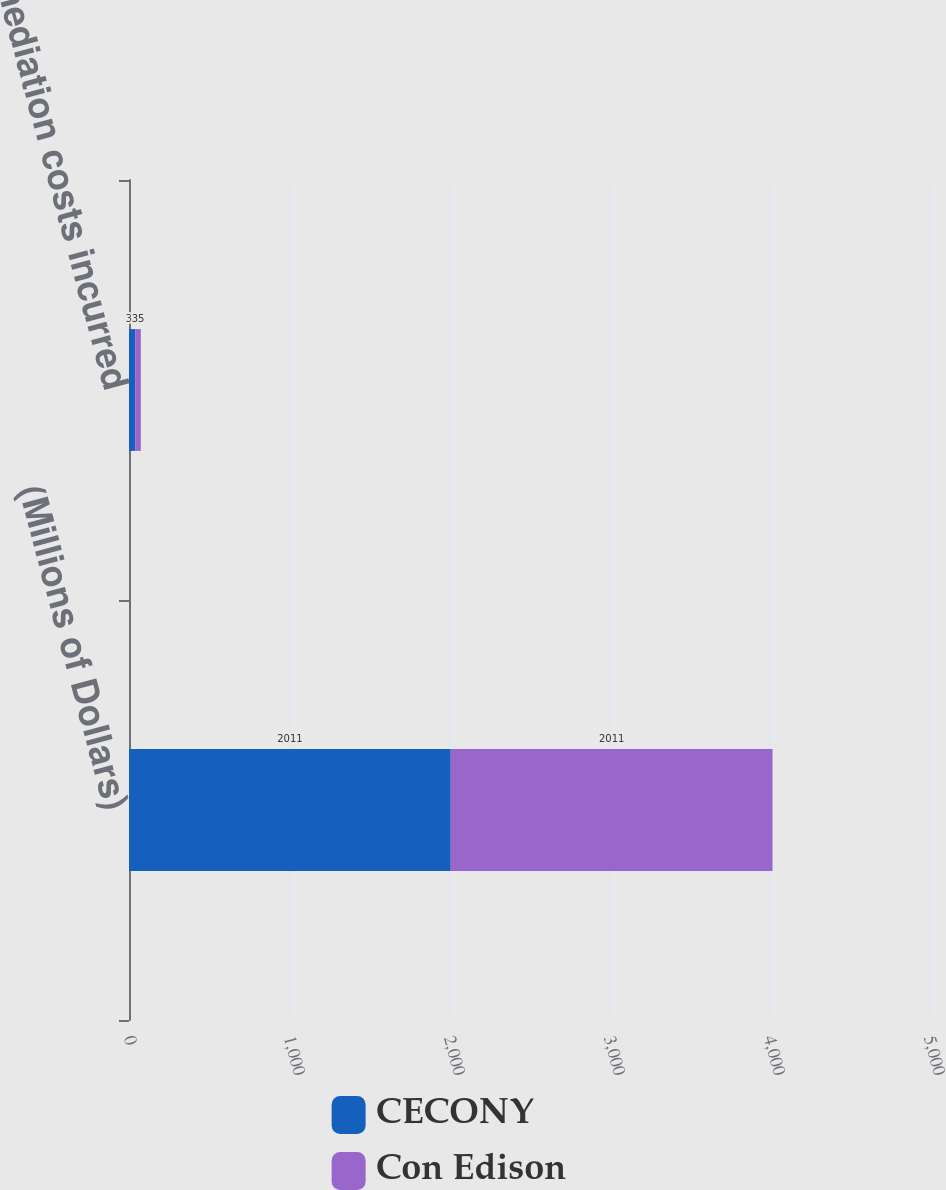Convert chart. <chart><loc_0><loc_0><loc_500><loc_500><stacked_bar_chart><ecel><fcel>(Millions of Dollars)<fcel>Remediation costs incurred<nl><fcel>CECONY<fcel>2011<fcel>39<nl><fcel>Con Edison<fcel>2011<fcel>35<nl></chart> 